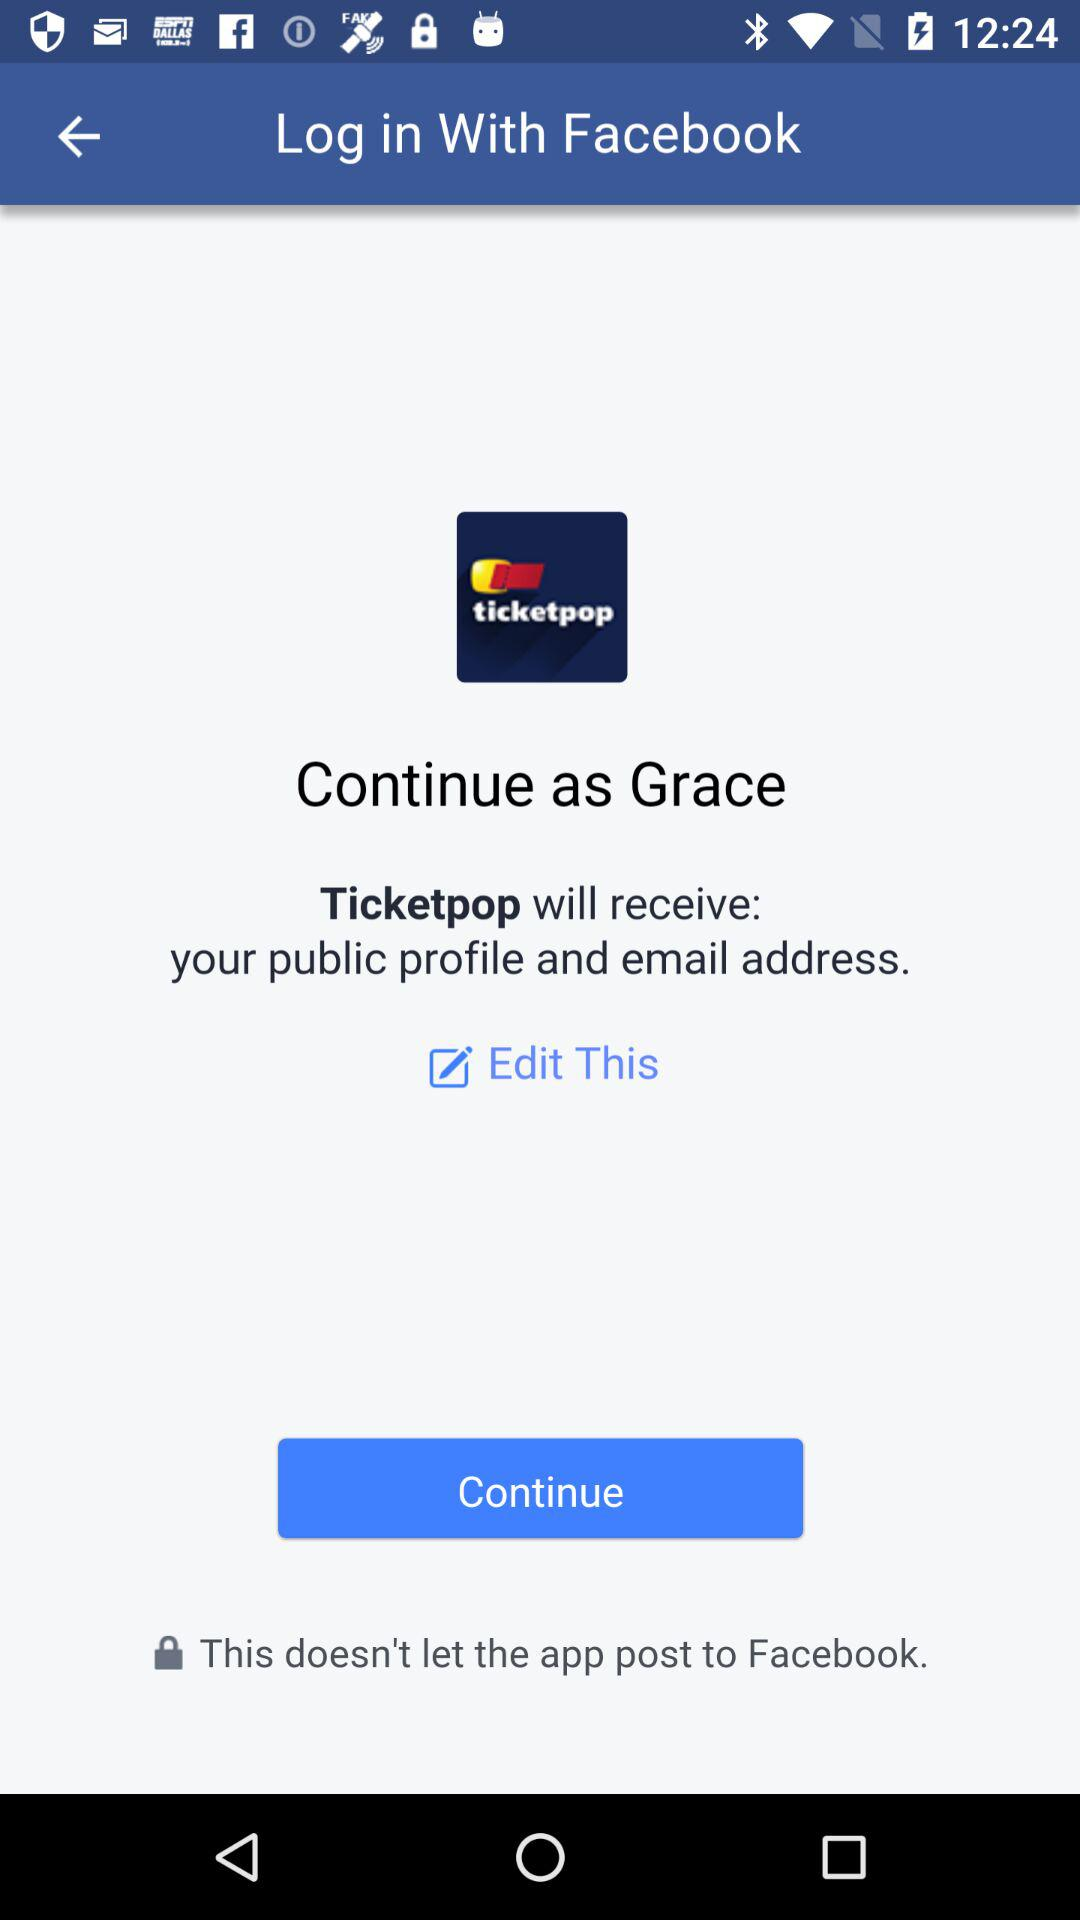What application is asking for permission? The application that is asking for permission is "Ticketpop". 